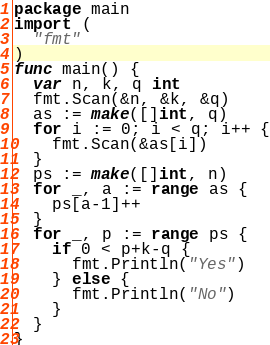Convert code to text. <code><loc_0><loc_0><loc_500><loc_500><_Go_>package main
import (
  "fmt"
)
func main() {
  var n, k, q int
  fmt.Scan(&n, &k, &q)
  as := make([]int, q)
  for i := 0; i < q; i++ {
    fmt.Scan(&as[i])
  }
  ps := make([]int, n)
  for _, a := range as {
    ps[a-1]++
  }
  for _, p := range ps {
    if 0 < p+k-q {
      fmt.Println("Yes")
    } else {
      fmt.Println("No")
    }
  }
}</code> 